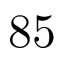<formula> <loc_0><loc_0><loc_500><loc_500>8 5</formula> 